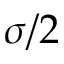<formula> <loc_0><loc_0><loc_500><loc_500>\sigma / 2</formula> 